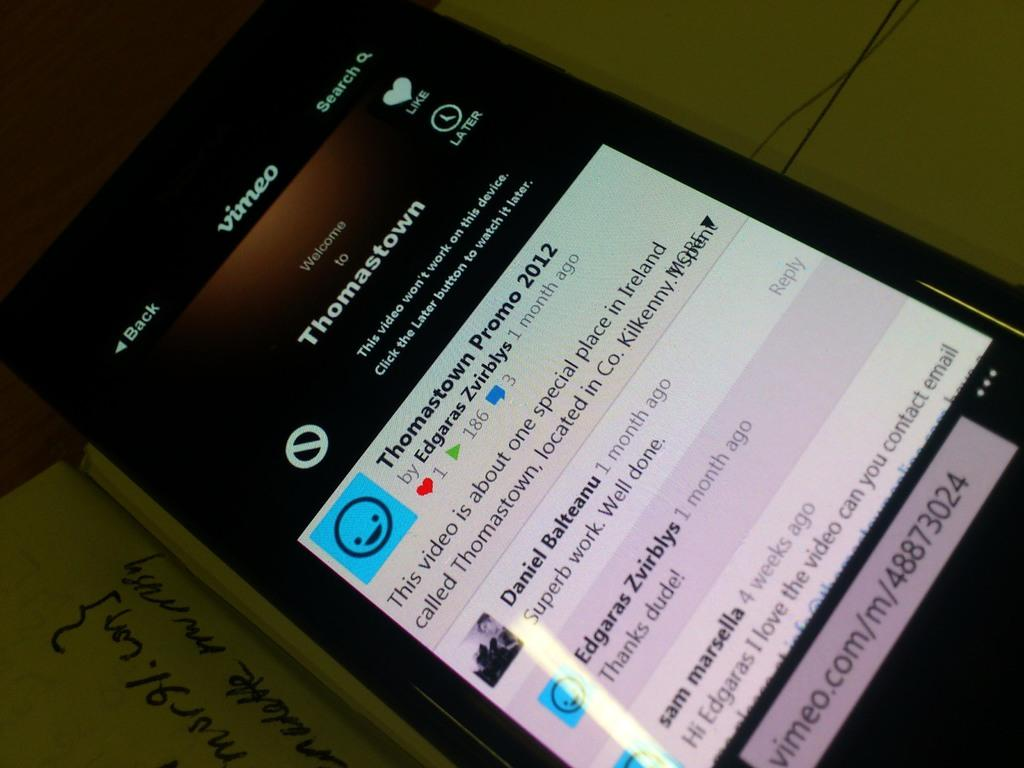<image>
Relay a brief, clear account of the picture shown. a cell phone displaying a page with Thomastown written on it 